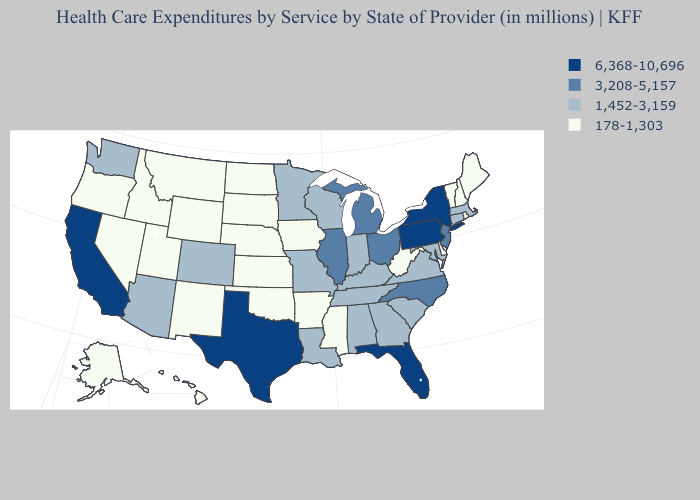Does Arizona have a higher value than South Carolina?
Be succinct. No. Name the states that have a value in the range 3,208-5,157?
Concise answer only. Illinois, Michigan, New Jersey, North Carolina, Ohio. Which states have the highest value in the USA?
Write a very short answer. California, Florida, New York, Pennsylvania, Texas. What is the value of Kentucky?
Quick response, please. 1,452-3,159. Is the legend a continuous bar?
Short answer required. No. Does South Carolina have the same value as Virginia?
Be succinct. Yes. How many symbols are there in the legend?
Short answer required. 4. Does Kansas have the highest value in the MidWest?
Short answer required. No. What is the highest value in states that border Texas?
Short answer required. 1,452-3,159. Which states have the lowest value in the USA?
Write a very short answer. Alaska, Arkansas, Delaware, Hawaii, Idaho, Iowa, Kansas, Maine, Mississippi, Montana, Nebraska, Nevada, New Hampshire, New Mexico, North Dakota, Oklahoma, Oregon, Rhode Island, South Dakota, Utah, Vermont, West Virginia, Wyoming. What is the value of Colorado?
Answer briefly. 1,452-3,159. Does Pennsylvania have the highest value in the Northeast?
Keep it brief. Yes. Does the first symbol in the legend represent the smallest category?
Answer briefly. No. Which states have the lowest value in the USA?
Quick response, please. Alaska, Arkansas, Delaware, Hawaii, Idaho, Iowa, Kansas, Maine, Mississippi, Montana, Nebraska, Nevada, New Hampshire, New Mexico, North Dakota, Oklahoma, Oregon, Rhode Island, South Dakota, Utah, Vermont, West Virginia, Wyoming. Does Rhode Island have a higher value than Mississippi?
Answer briefly. No. 